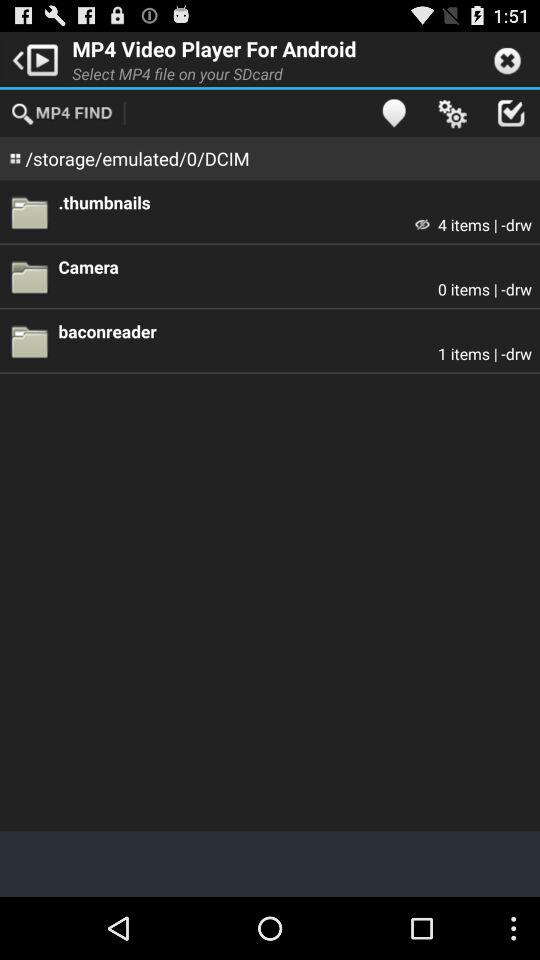How many items are there in the camera file? There are 0 items in the camera file. 